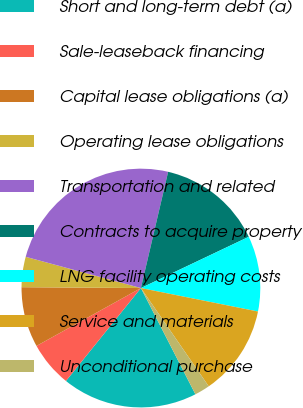Convert chart to OTSL. <chart><loc_0><loc_0><loc_500><loc_500><pie_chart><fcel>Short and long-term debt (a)<fcel>Sale-leaseback financing<fcel>Capital lease obligations (a)<fcel>Operating lease obligations<fcel>Transportation and related<fcel>Contracts to acquire property<fcel>LNG facility operating costs<fcel>Service and materials<fcel>Unconditional purchase<nl><fcel>18.35%<fcel>6.14%<fcel>8.17%<fcel>4.1%<fcel>24.45%<fcel>14.28%<fcel>10.21%<fcel>12.24%<fcel>2.07%<nl></chart> 